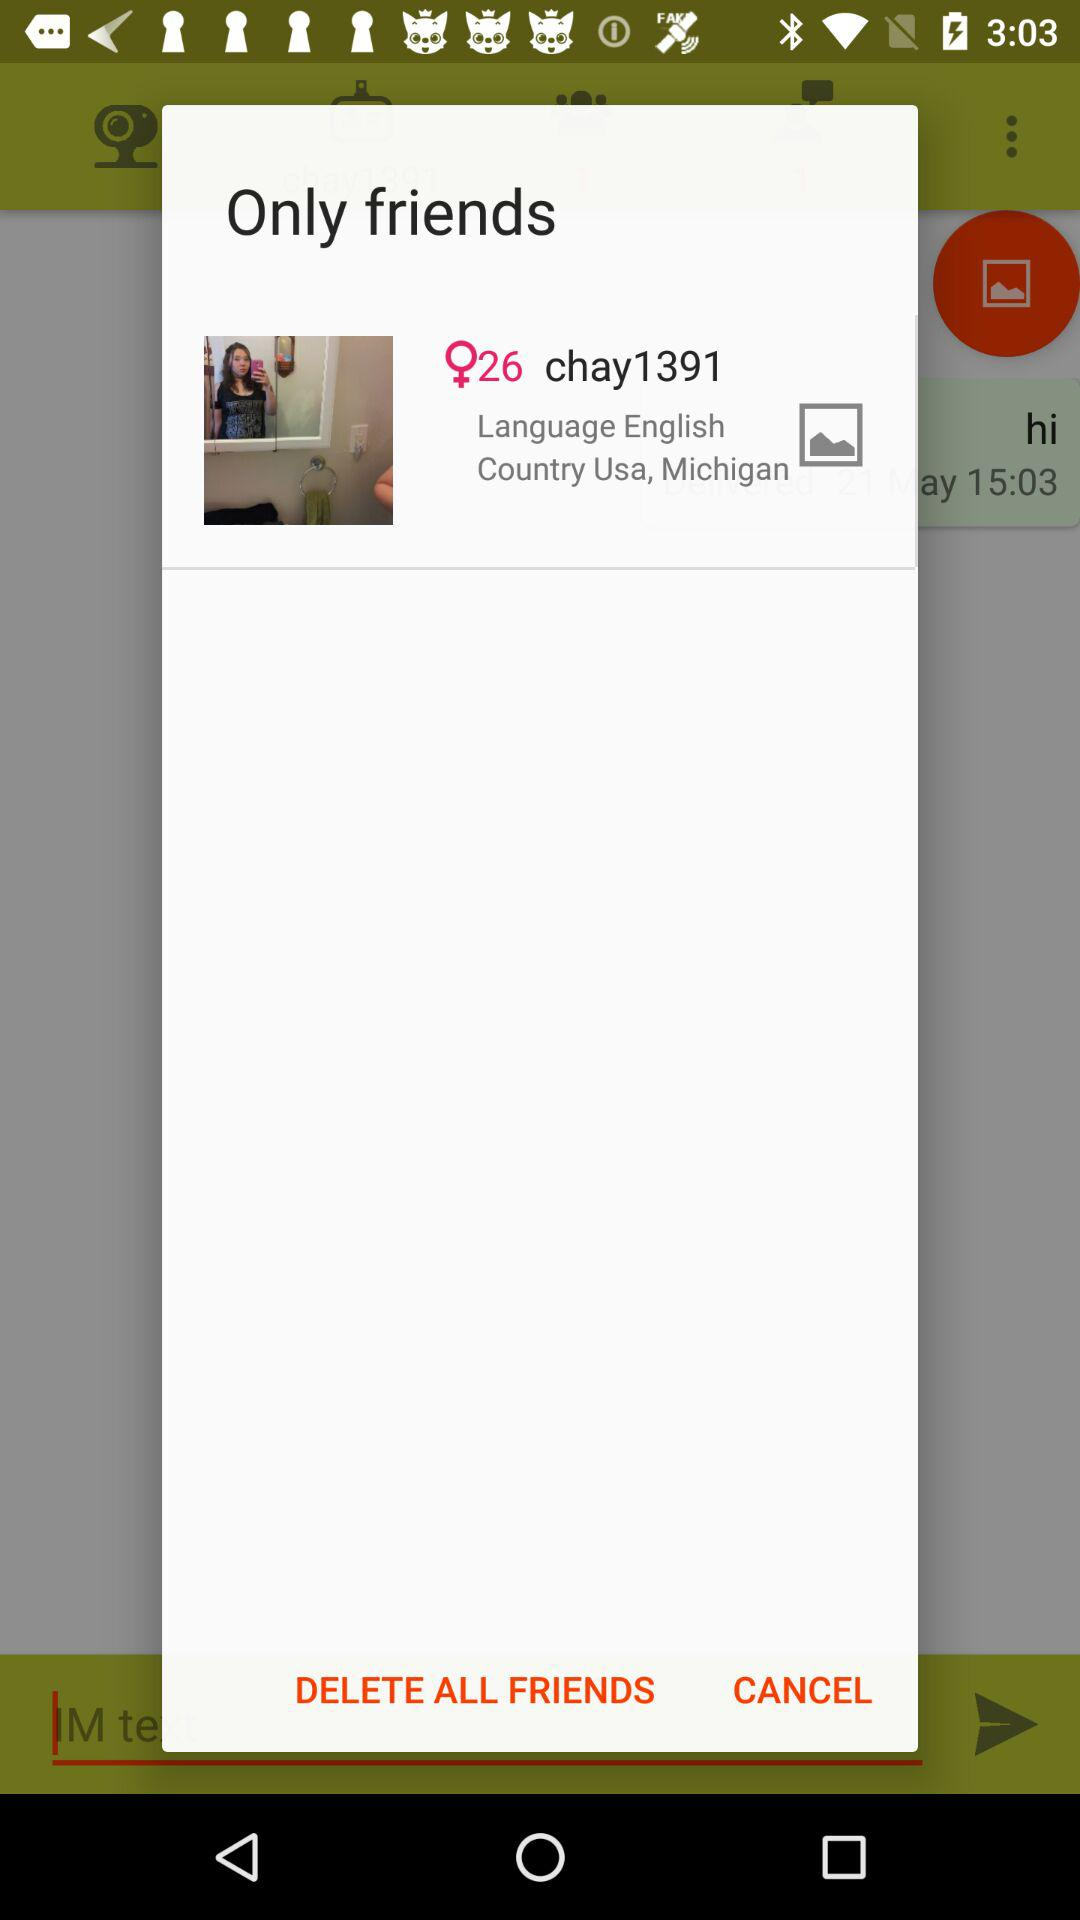What is the gender? The gender is female. 